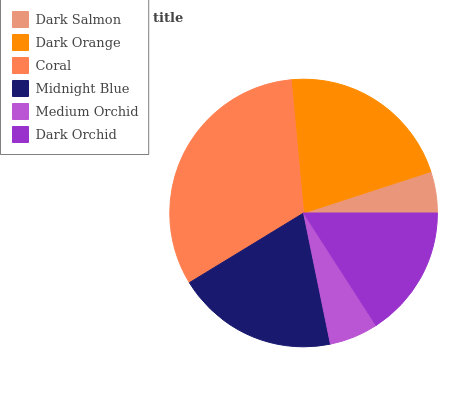Is Dark Salmon the minimum?
Answer yes or no. Yes. Is Coral the maximum?
Answer yes or no. Yes. Is Dark Orange the minimum?
Answer yes or no. No. Is Dark Orange the maximum?
Answer yes or no. No. Is Dark Orange greater than Dark Salmon?
Answer yes or no. Yes. Is Dark Salmon less than Dark Orange?
Answer yes or no. Yes. Is Dark Salmon greater than Dark Orange?
Answer yes or no. No. Is Dark Orange less than Dark Salmon?
Answer yes or no. No. Is Midnight Blue the high median?
Answer yes or no. Yes. Is Dark Orchid the low median?
Answer yes or no. Yes. Is Dark Orchid the high median?
Answer yes or no. No. Is Coral the low median?
Answer yes or no. No. 